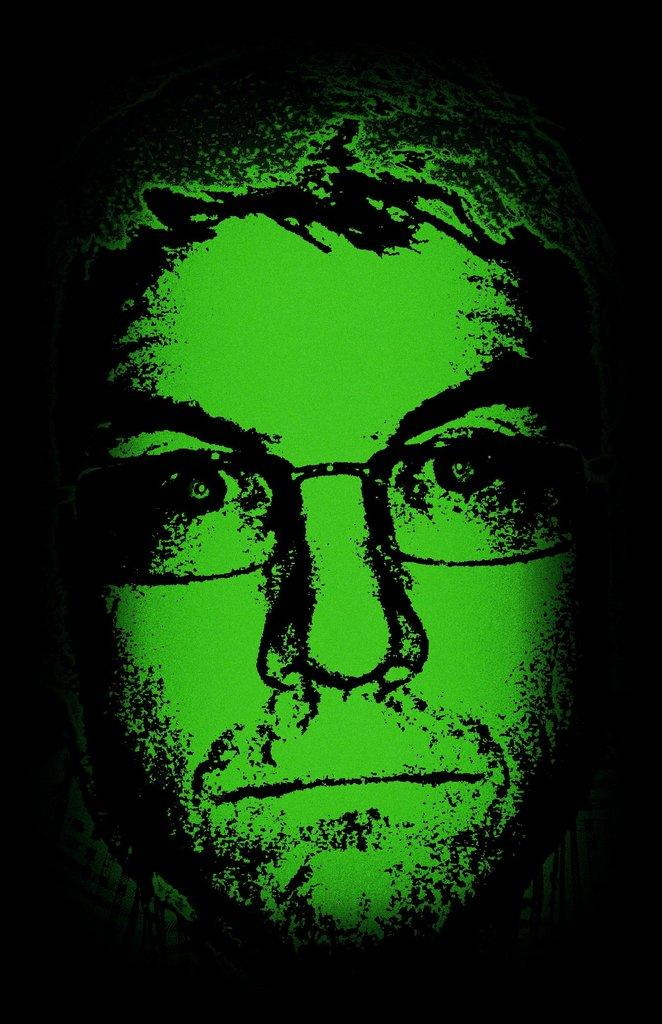What is the main subject of the image? There is a person's face in the image. Has the image been altered in any way? Yes, the image has been edited. What can be observed about the background of the image? The background of the image is dark. What type of sponge can be seen in the image? There is no sponge present in the image. Is the person in the image taking a bath in the tub? There is no tub or indication of bathing in the image; it only features a person's face. 